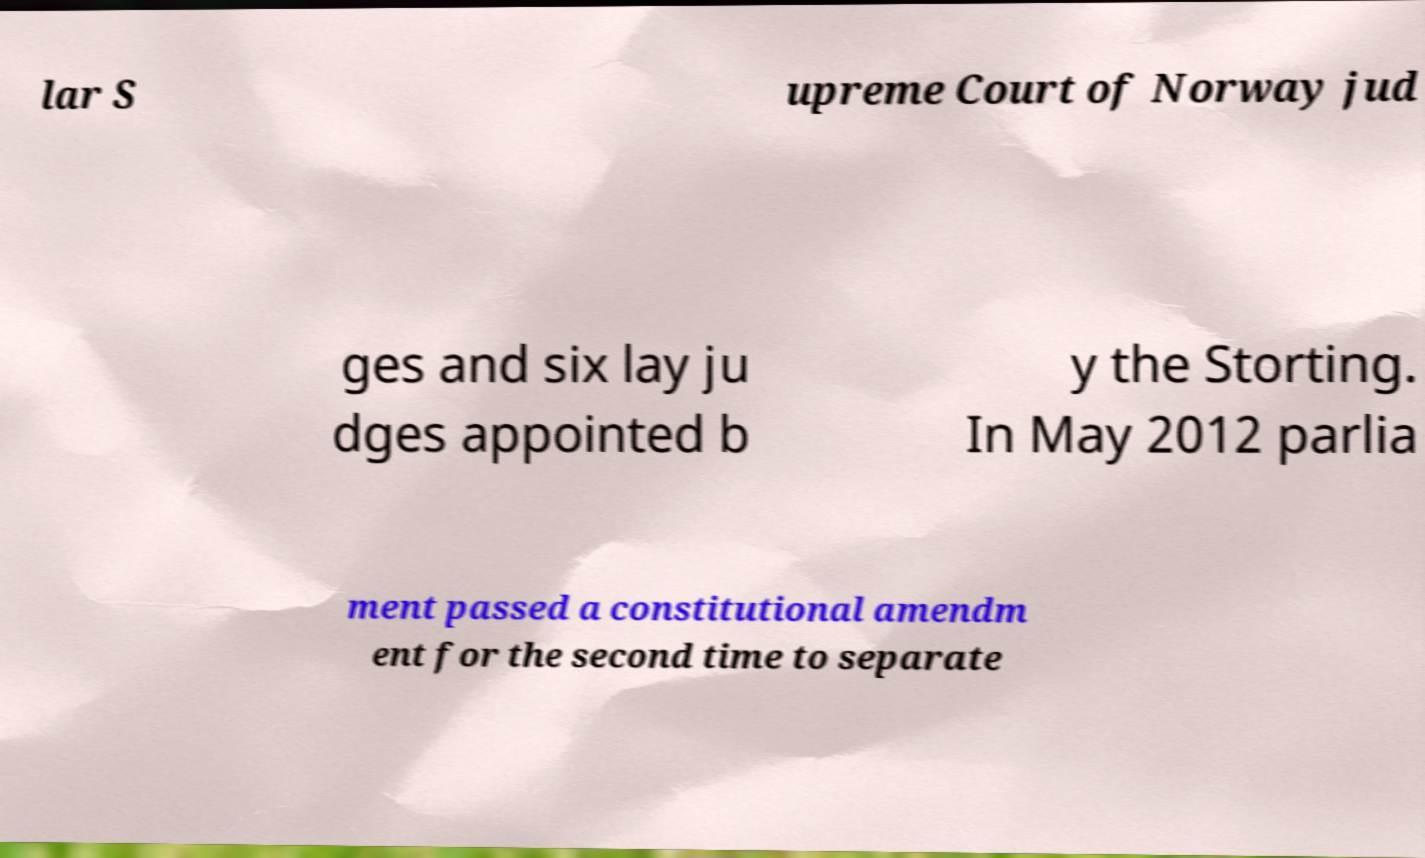I need the written content from this picture converted into text. Can you do that? lar S upreme Court of Norway jud ges and six lay ju dges appointed b y the Storting. In May 2012 parlia ment passed a constitutional amendm ent for the second time to separate 